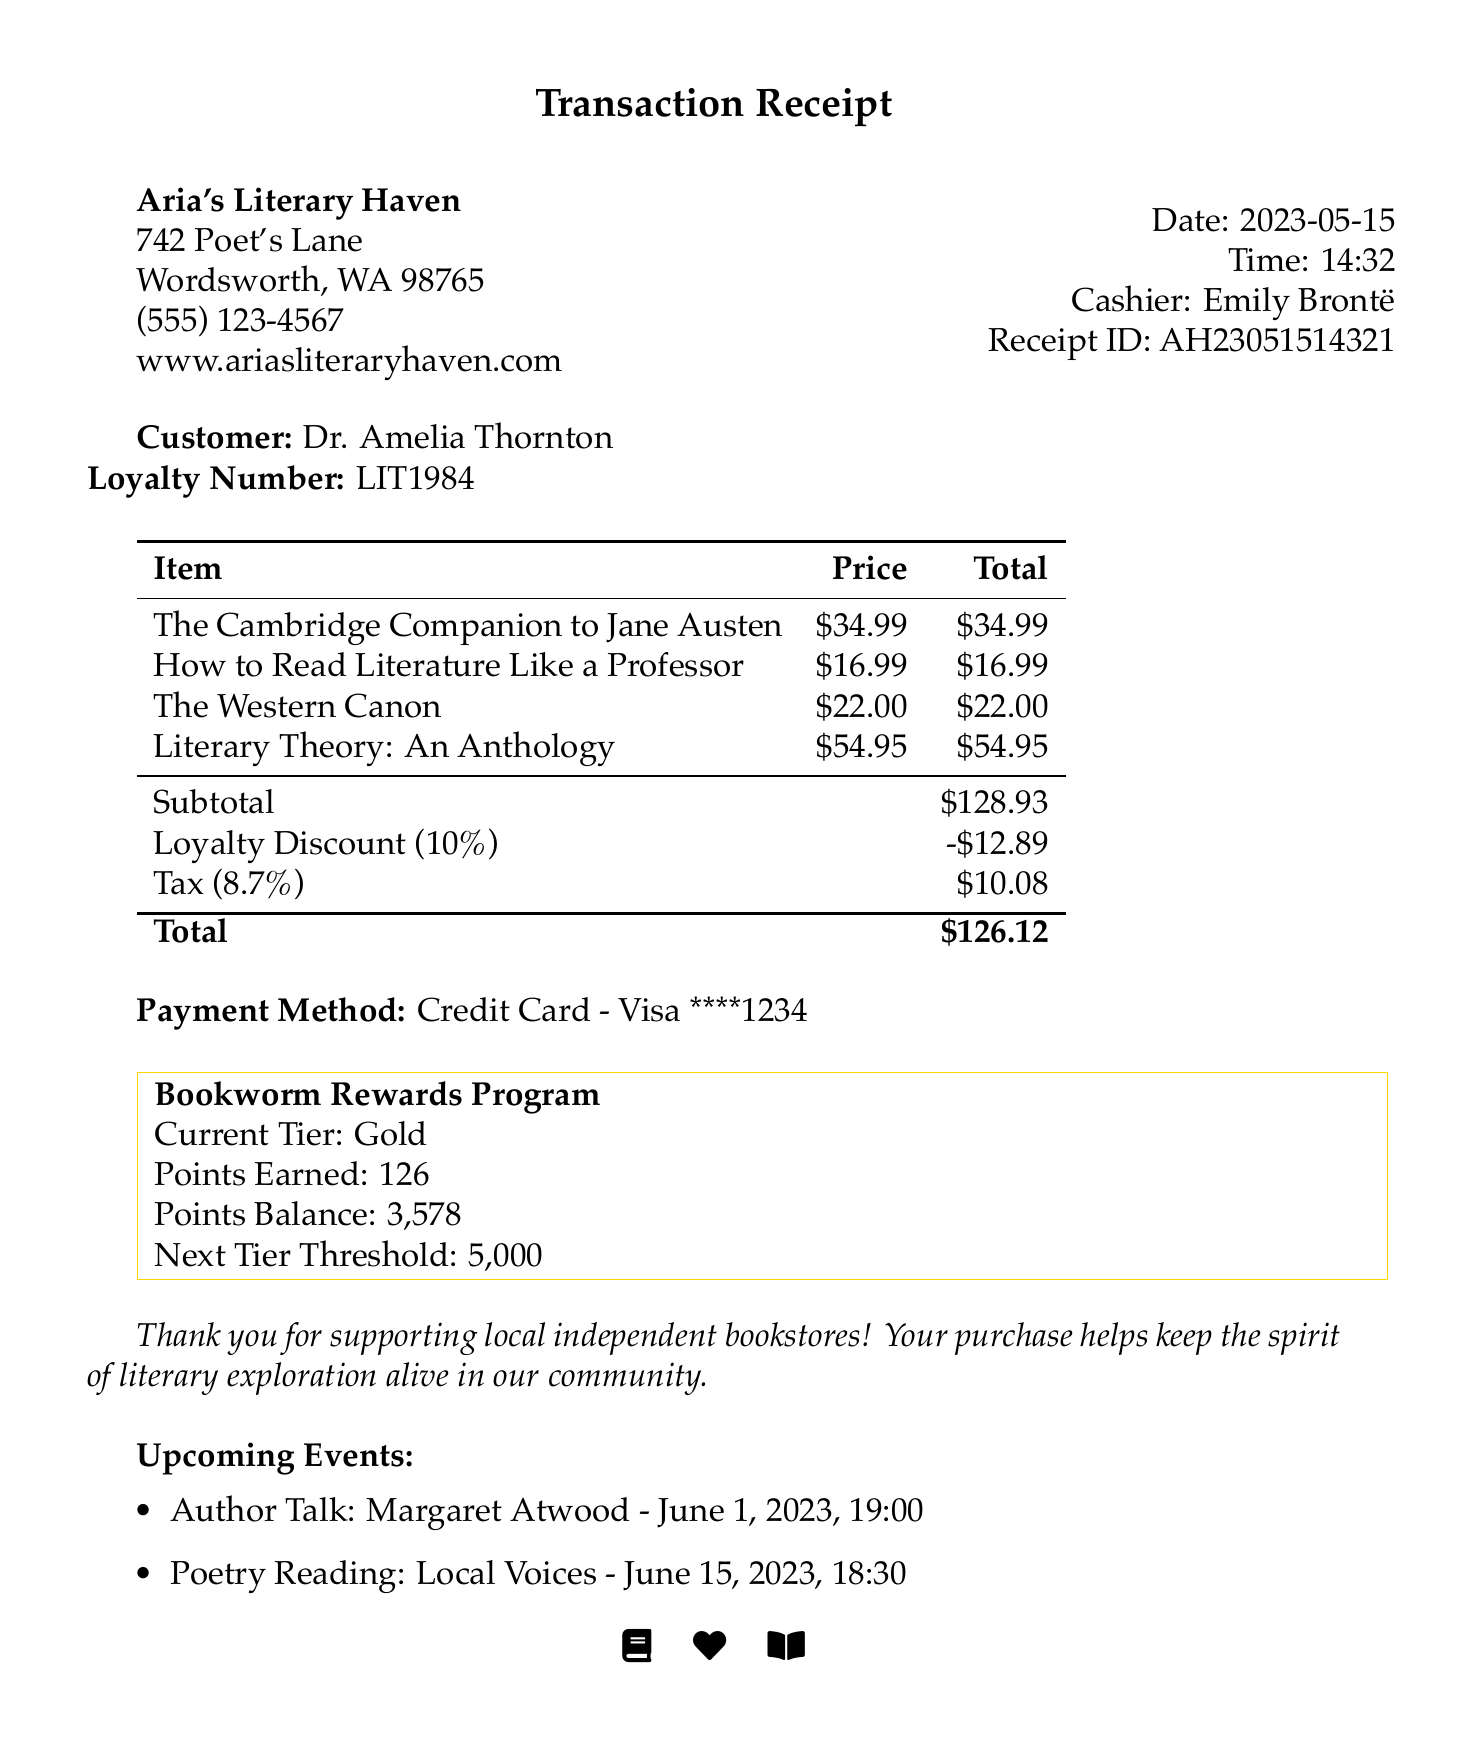What is the name of the bookstore? The name of the bookstore is clearly stated at the top of the document.
Answer: Aria's Literary Haven Who was the cashier for this transaction? The name of the cashier is listed in the receipt document.
Answer: Emily Brontë What is the total amount spent by the customer? The total amount is prominently shown at the end of the itemized list.
Answer: $126.12 How much was the loyalty discount? The loyalty discount amount is specifically stated in the subtotal section.
Answer: $12.89 What is the price of "How to Read Literature Like a Professor"? The price of the book is provided as part of the itemized list.
Answer: $16.99 How many loyalty points were earned in this transaction? The number of loyalty points earned is displayed in the loyalty program section.
Answer: 126 What is the next tier threshold in the loyalty program? The next tier threshold is mentioned within the loyalty program details.
Answer: 5000 When is the Author Talk event scheduled? The date and time for the upcoming Author Talk event are included in the events section.
Answer: June 1, 2023, 19:00 What payment method was used? The payment method is indicated in the receipt details.
Answer: Credit Card - Visa ****1234 